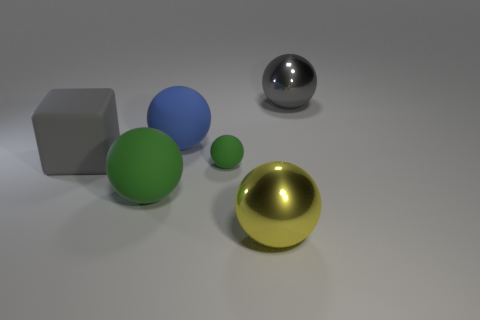Subtract 1 balls. How many balls are left? 4 Subtract all small rubber spheres. How many spheres are left? 4 Subtract all yellow balls. How many balls are left? 4 Subtract all cyan balls. Subtract all green cubes. How many balls are left? 5 Add 2 big gray rubber objects. How many objects exist? 8 Subtract all spheres. How many objects are left? 1 Add 3 green objects. How many green objects exist? 5 Subtract 0 cyan spheres. How many objects are left? 6 Subtract all blue matte balls. Subtract all metal balls. How many objects are left? 3 Add 5 blue balls. How many blue balls are left? 6 